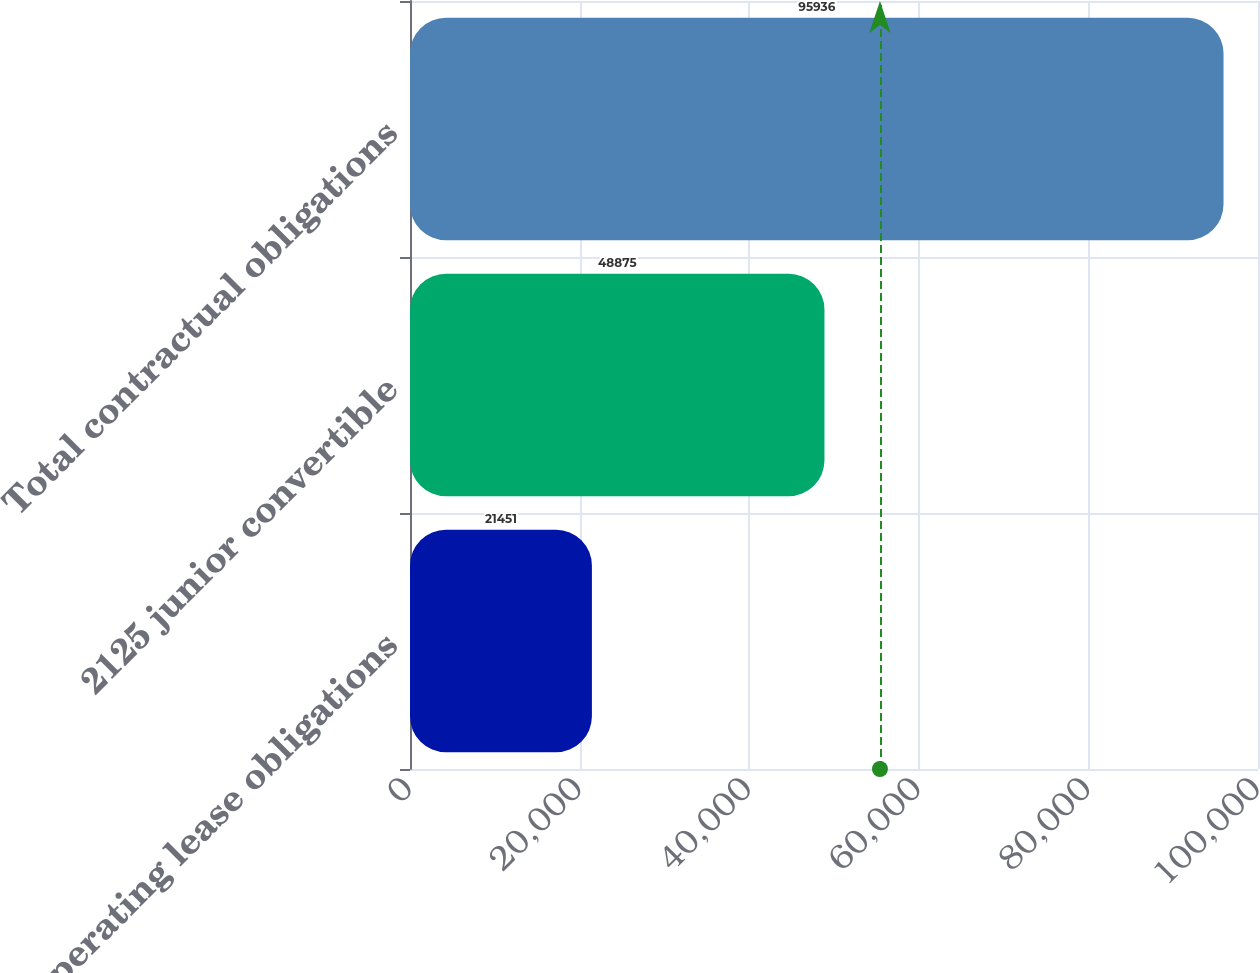Convert chart to OTSL. <chart><loc_0><loc_0><loc_500><loc_500><bar_chart><fcel>Operating lease obligations<fcel>2125 junior convertible<fcel>Total contractual obligations<nl><fcel>21451<fcel>48875<fcel>95936<nl></chart> 